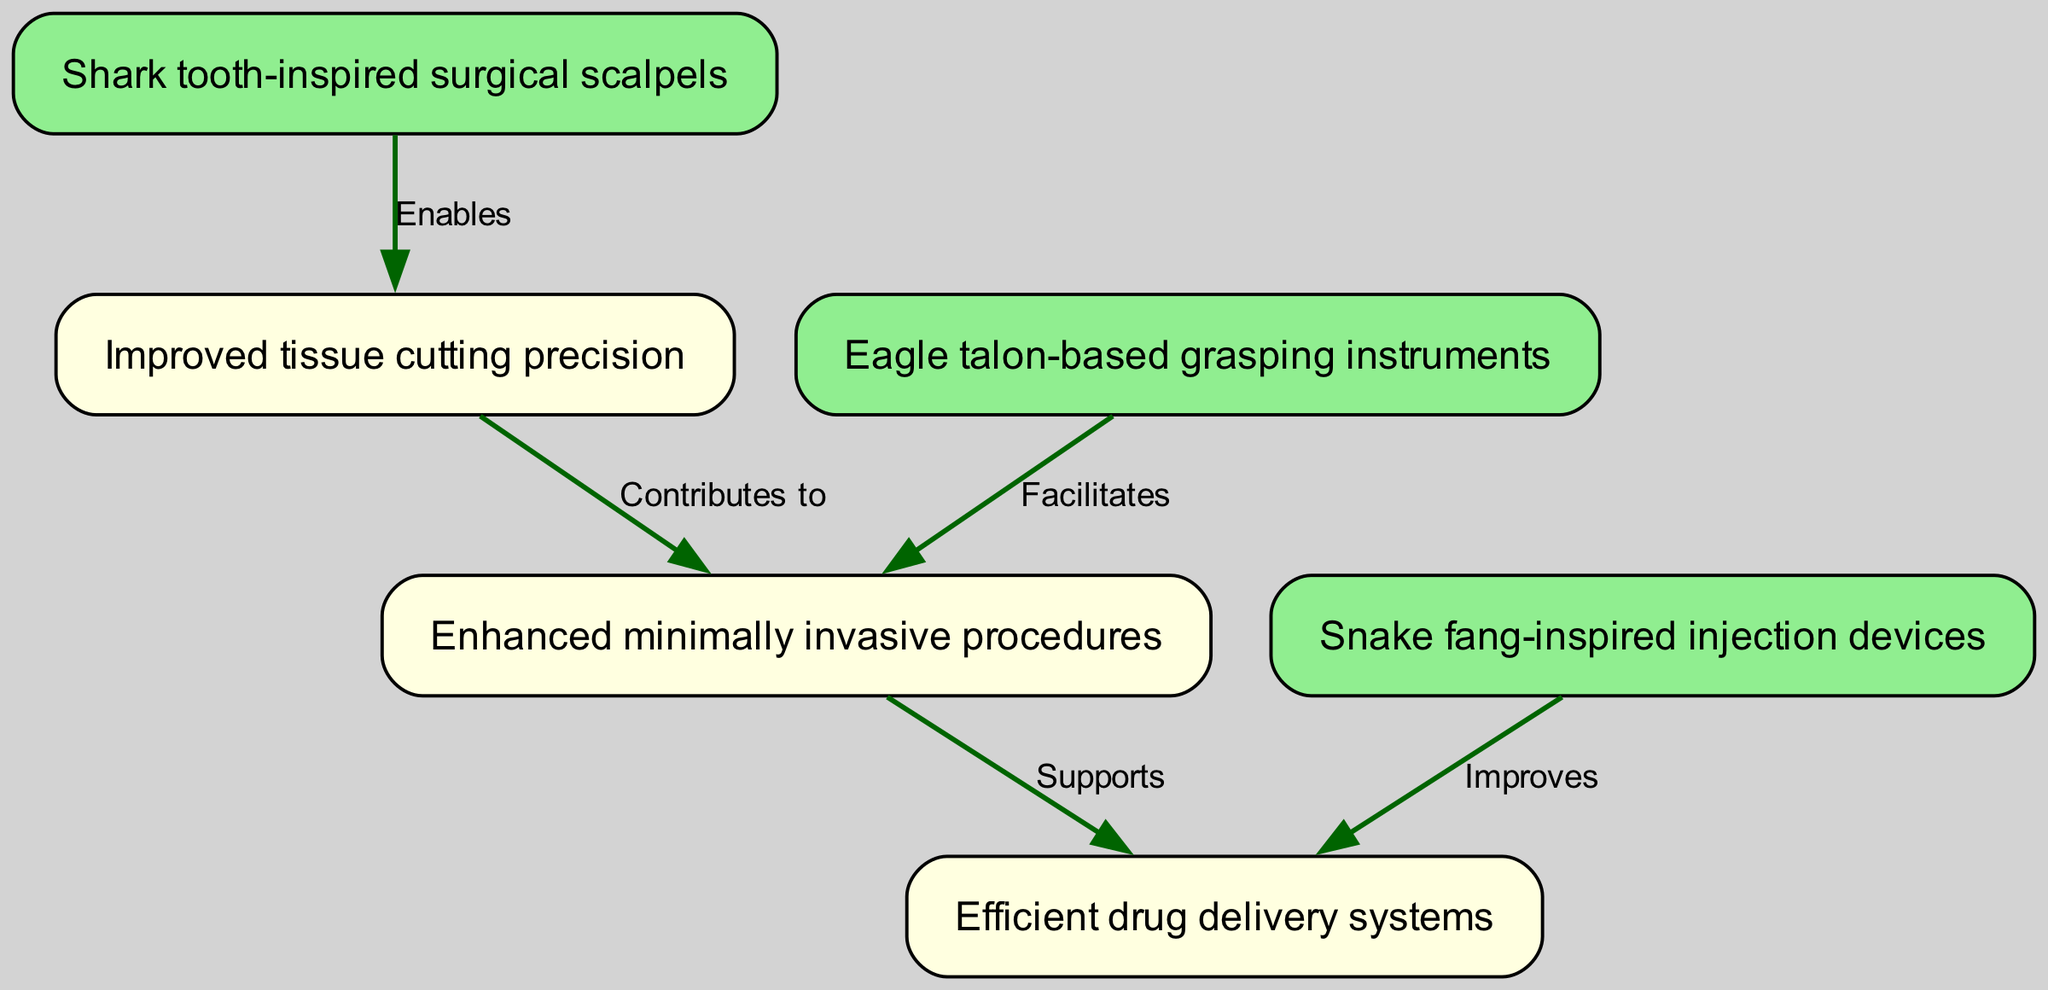What are the surgical tools inspired by animal adaptations? The diagram lists three surgical tools inspired by animal adaptations: shark tooth-inspired surgical scalpels, eagle talon-based grasping instruments, and snake fang-inspired injection devices. Each represents an innovation derived from the anatomical features of those predators.
Answer: shark tooth-inspired surgical scalpels, eagle talon-based grasping instruments, snake fang-inspired injection devices How many outcomes are shown in the diagram? The diagram depicts three outcomes, which are improved tissue cutting precision, enhanced minimally invasive procedures, and efficient drug delivery systems. To determine the count, one can simply observe the nodes categorized under outcomes (nodes 4, 5, and 6).
Answer: 3 What does the eagle talon-based grasping instruments facilitate? The eagle talon-based grasping instruments facilitate enhanced minimally invasive procedures. This relationship is illustrated in the diagram by the connecting edge labeled "Facilitates" between the eagle talon node and the minimally invasive procedures node.
Answer: enhanced minimally invasive procedures Which surgical tool improves efficient drug delivery systems? Snake fang-inspired injection devices improve efficient drug delivery systems. This relationship is indicated by the directed edge labeled "Improves" connecting the snake fang node to the efficient drug delivery systems node in the diagram.
Answer: efficient drug delivery systems What is the relationship between improved tissue cutting precision and enhanced minimally invasive procedures? Improved tissue cutting precision contributes to enhanced minimally invasive procedures. This means that achieving higher precision in cutting directly supports the effectiveness or efficiency of minimally invasive approaches, as per the labeled connection between nodes 4 and 5.
Answer: contributes to How many edges exist between the nodes in the diagram? The diagram contains five edges that represent relationships between the surgical tools and the outcomes. Each edge indicates a specific relation such as "Enables," "Facilitates," "Improves," "Contributes to," and "Supports."
Answer: 5 Which surgical tool enables improved tissue cutting precision? Shark tooth-inspired surgical scalpels enable improved tissue cutting precision. The connection labeled "Enables" directly connects the shark tool with the precision cutting outcome, establishing that utilizing the scalpel leads to better precision.
Answer: improved tissue cutting precision What supports efficient drug delivery systems? Enhanced minimally invasive procedures support efficient drug delivery systems. The diagram shows that this relationship is established through the labeled edge connecting the outcomes of enhanced procedures to the drug delivery systems.
Answer: supports 